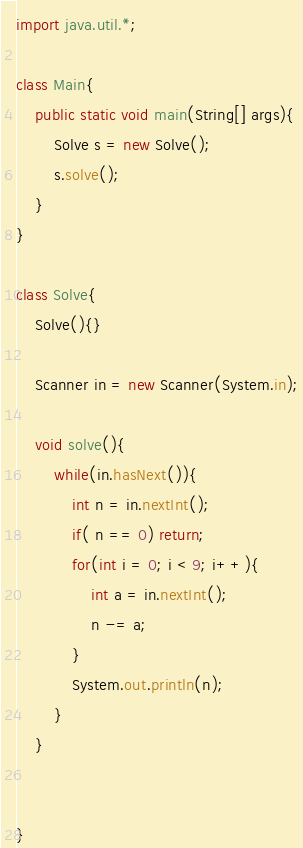<code> <loc_0><loc_0><loc_500><loc_500><_Java_>import java.util.*;

class Main{
	public static void main(String[] args){
		Solve s = new Solve();
		s.solve();
	}	
}

class Solve{
	Solve(){}
	
	Scanner in = new Scanner(System.in);

	void solve(){
		while(in.hasNext()){
			int n = in.nextInt();
			if( n == 0) return;
			for(int i = 0; i < 9; i++){
				int a = in.nextInt();
				n -= a;
			}
			System.out.println(n);
		}
	}

	
}</code> 